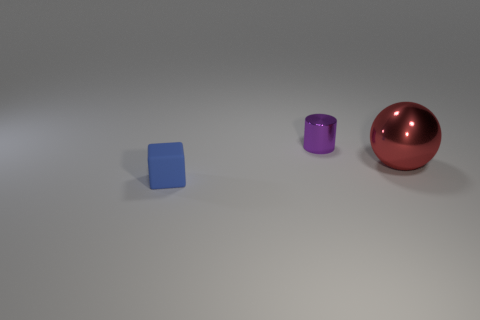Are there fewer purple things behind the large metal sphere than red shiny spheres?
Your answer should be very brief. No. Is there any other thing that is the same size as the blue matte thing?
Provide a short and direct response. Yes. Is the material of the sphere the same as the tiny purple object?
Offer a terse response. Yes. What number of things are things that are behind the tiny blue cube or tiny things that are right of the tiny matte object?
Your answer should be very brief. 2. Is there a red shiny object of the same size as the rubber block?
Ensure brevity in your answer.  No. There is a shiny object behind the big red shiny sphere; are there any blocks behind it?
Provide a short and direct response. No. Does the shiny object that is on the right side of the small cylinder have the same shape as the blue object?
Provide a succinct answer. No. What is the shape of the tiny shiny object?
Offer a terse response. Cylinder. How many small blue things have the same material as the purple cylinder?
Offer a terse response. 0. Do the small rubber object and the thing that is behind the big metal thing have the same color?
Give a very brief answer. No. 